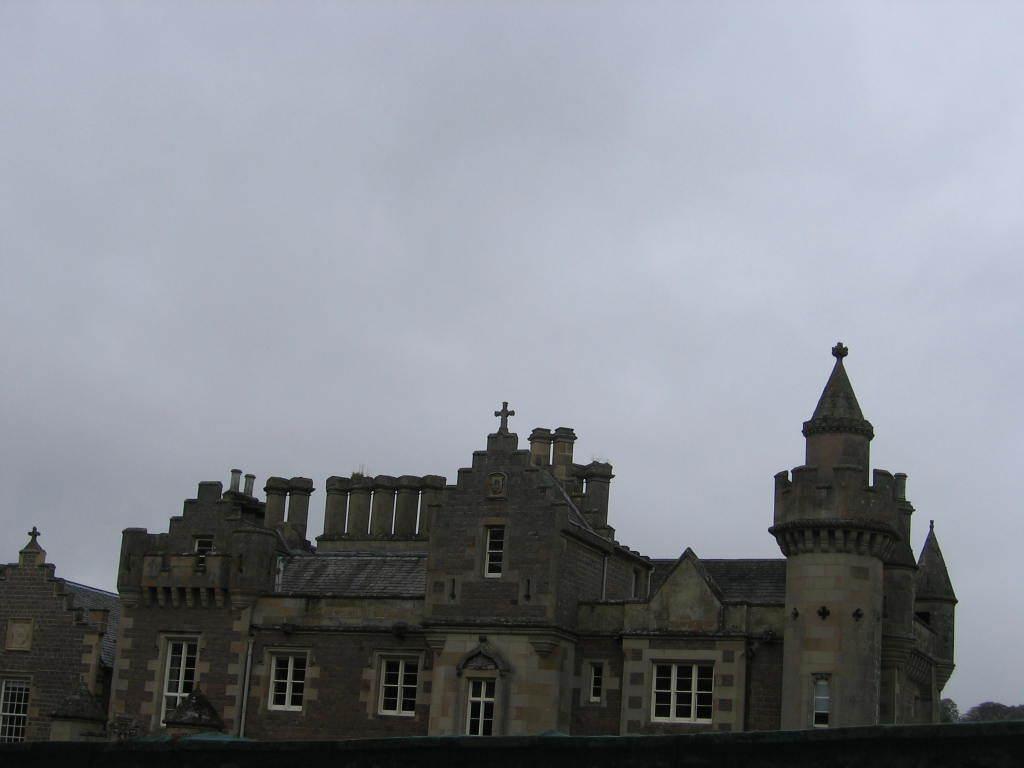How would you summarize this image in a sentence or two? In this image, we can see a building and at the top, there is a sky. 